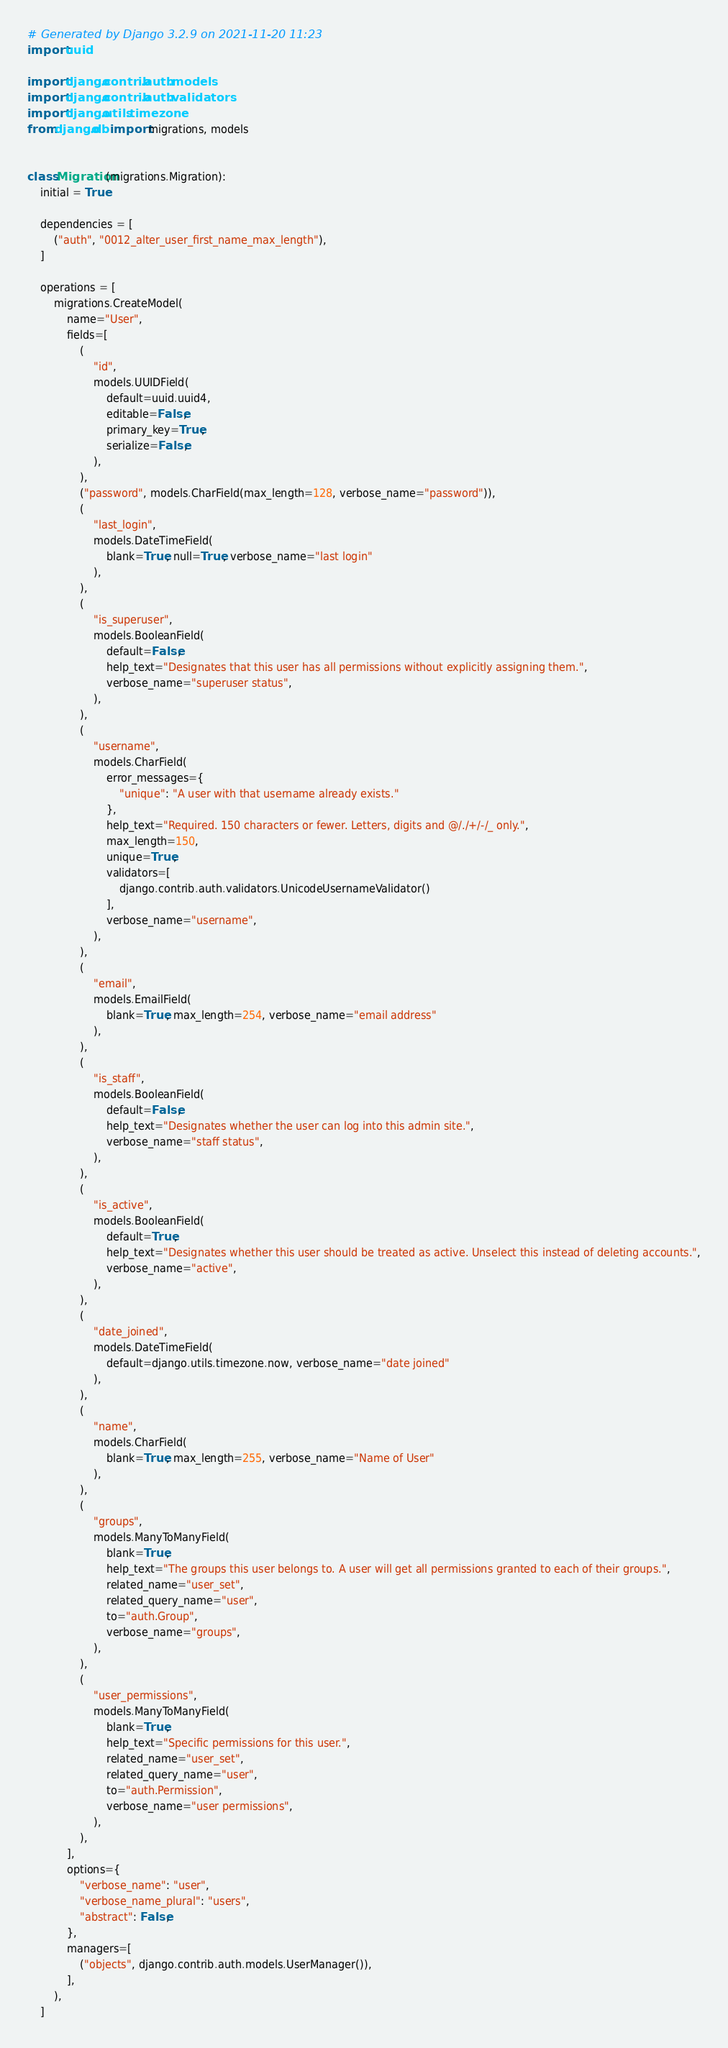<code> <loc_0><loc_0><loc_500><loc_500><_Python_># Generated by Django 3.2.9 on 2021-11-20 11:23
import uuid

import django.contrib.auth.models
import django.contrib.auth.validators
import django.utils.timezone
from django.db import migrations, models


class Migration(migrations.Migration):
    initial = True

    dependencies = [
        ("auth", "0012_alter_user_first_name_max_length"),
    ]

    operations = [
        migrations.CreateModel(
            name="User",
            fields=[
                (
                    "id",
                    models.UUIDField(
                        default=uuid.uuid4,
                        editable=False,
                        primary_key=True,
                        serialize=False,
                    ),
                ),
                ("password", models.CharField(max_length=128, verbose_name="password")),
                (
                    "last_login",
                    models.DateTimeField(
                        blank=True, null=True, verbose_name="last login"
                    ),
                ),
                (
                    "is_superuser",
                    models.BooleanField(
                        default=False,
                        help_text="Designates that this user has all permissions without explicitly assigning them.",
                        verbose_name="superuser status",
                    ),
                ),
                (
                    "username",
                    models.CharField(
                        error_messages={
                            "unique": "A user with that username already exists."
                        },
                        help_text="Required. 150 characters or fewer. Letters, digits and @/./+/-/_ only.",
                        max_length=150,
                        unique=True,
                        validators=[
                            django.contrib.auth.validators.UnicodeUsernameValidator()
                        ],
                        verbose_name="username",
                    ),
                ),
                (
                    "email",
                    models.EmailField(
                        blank=True, max_length=254, verbose_name="email address"
                    ),
                ),
                (
                    "is_staff",
                    models.BooleanField(
                        default=False,
                        help_text="Designates whether the user can log into this admin site.",
                        verbose_name="staff status",
                    ),
                ),
                (
                    "is_active",
                    models.BooleanField(
                        default=True,
                        help_text="Designates whether this user should be treated as active. Unselect this instead of deleting accounts.",
                        verbose_name="active",
                    ),
                ),
                (
                    "date_joined",
                    models.DateTimeField(
                        default=django.utils.timezone.now, verbose_name="date joined"
                    ),
                ),
                (
                    "name",
                    models.CharField(
                        blank=True, max_length=255, verbose_name="Name of User"
                    ),
                ),
                (
                    "groups",
                    models.ManyToManyField(
                        blank=True,
                        help_text="The groups this user belongs to. A user will get all permissions granted to each of their groups.",
                        related_name="user_set",
                        related_query_name="user",
                        to="auth.Group",
                        verbose_name="groups",
                    ),
                ),
                (
                    "user_permissions",
                    models.ManyToManyField(
                        blank=True,
                        help_text="Specific permissions for this user.",
                        related_name="user_set",
                        related_query_name="user",
                        to="auth.Permission",
                        verbose_name="user permissions",
                    ),
                ),
            ],
            options={
                "verbose_name": "user",
                "verbose_name_plural": "users",
                "abstract": False,
            },
            managers=[
                ("objects", django.contrib.auth.models.UserManager()),
            ],
        ),
    ]
</code> 